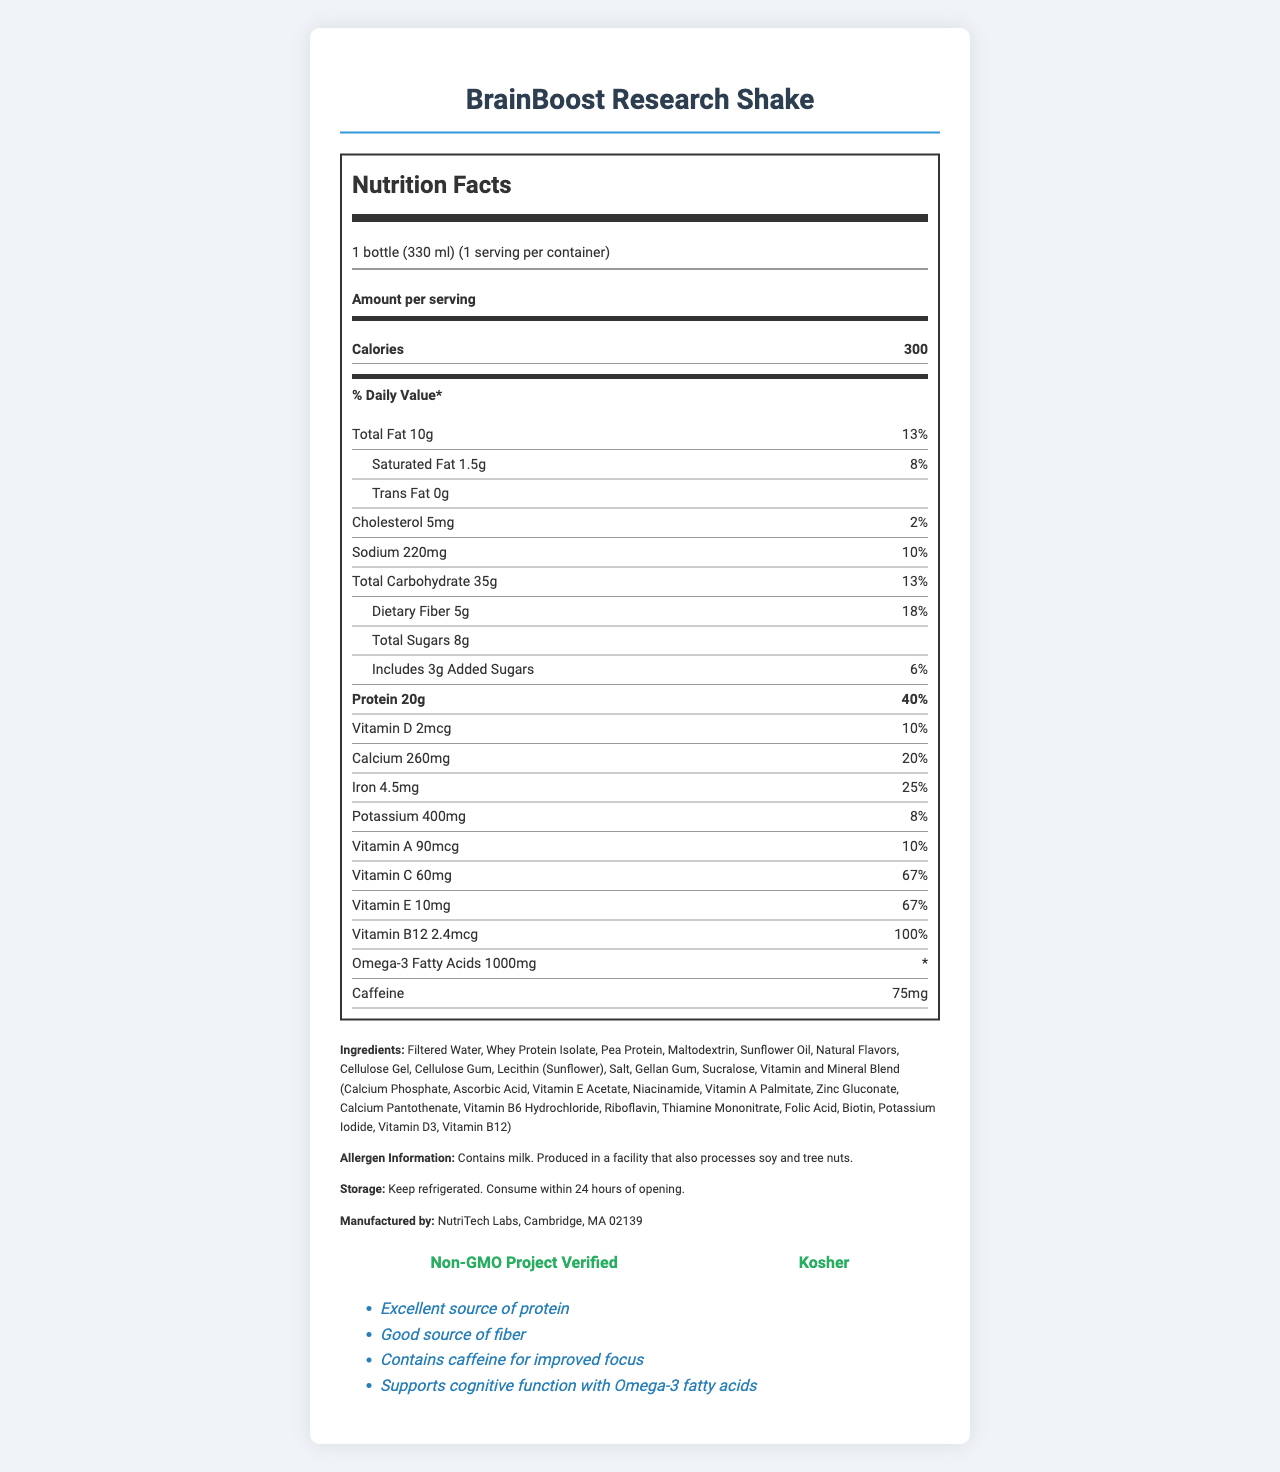what is the serving size for the BrainBoost Research Shake? The serving size is clearly listed on the document as "1 bottle (330 ml)."
Answer: 1 bottle (330 ml) how many calories are there per serving? The calories per serving are stated directly in the nutrition label as "300."
Answer: 300 what is the total fat content and its daily value percentage? The document lists "Total Fat 10g" and "13%" for the daily value percentage.
Answer: 10g (13%) how much sodium does the shake contain? The sodium content is listed in the nutrition label as "220mg."
Answer: 220mg what are the main allergens mentioned? The allergen information states "Contains milk. Produced in a facility that also processes soy and tree nuts."
Answer: milk, soy, tree nuts which vitamins have their daily value percentage listed as 10%? A. Vitamin A and Vitamin D B. Vitamin D and Calcium C. Vitamin A and Vitamin B12 The percentages for Vitamin A and Vitamin D are both listed as "10%."
Answer: A. Vitamin A and Vitamin D how much caffeine does the BrainBoost Research Shake contain? A. 50mg B. 75mg C. 100mg The nutritional information lists the caffeine content as "75mg."
Answer: B. 75mg is the product certified as Non-GMO? One of the certifications listed in the document is "Non-GMO Project Verified."
Answer: Yes summarize the main nutritional highlights of the BrainBoost Research Shake. This comprehensive summary reflects the essential nutritional information, notable vitamin and mineral content, and certification details mentioned on the document.
Answer: The BrainBoost Research Shake provides 300 calories per serving with significant amounts of protein (20g, 40% DV) and dietary fiber (5g, 18% DV). It includes various vitamins and minerals like Vitamin C (67% DV), Vitamin E (67% DV), and Vitamin B12 (100% DV). The shake also contains omega-3 fatty acids and caffeine, making it supportive of cognitive functions, and it is certified as Non-GMO and Kosher. what energy sources does the BrainBoost Research Shake use? The document does not specifically list the energy sources used in the BrainBoost Research Shake.
Answer: Cannot be determined 